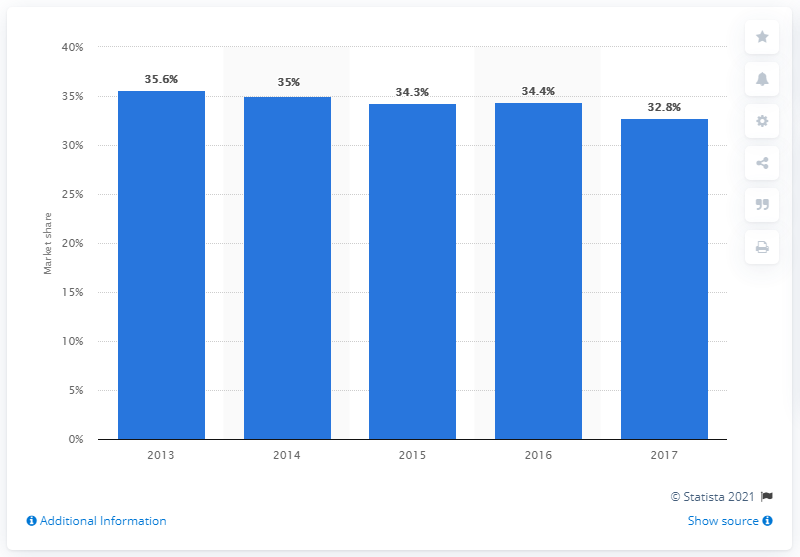Indicate a few pertinent items in this graphic. In 2017, the market share of Pedigree in India was 32.8%. The Compounded Annual Growth Rate (CAGR) of Pedigree between 2013 and 2017 was 32.8%. 